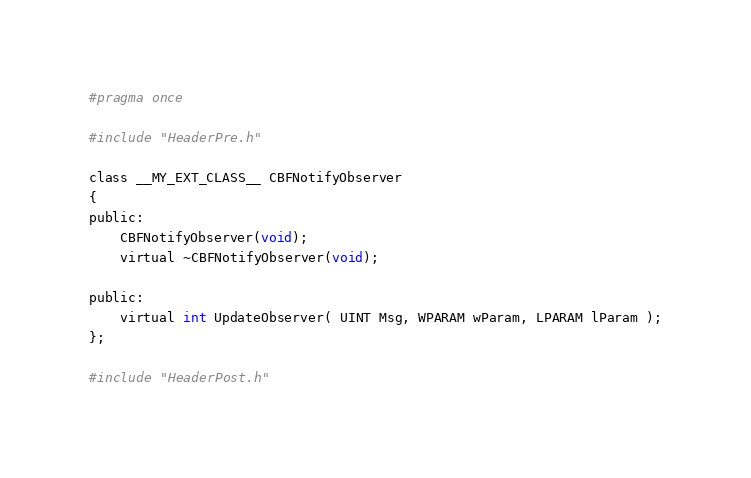Convert code to text. <code><loc_0><loc_0><loc_500><loc_500><_C_>#pragma once

#include "HeaderPre.h"

class __MY_EXT_CLASS__ CBFNotifyObserver
{
public:
	CBFNotifyObserver(void);
	virtual ~CBFNotifyObserver(void);

public:
	virtual int UpdateObserver( UINT Msg, WPARAM wParam, LPARAM lParam );
};

#include "HeaderPost.h"</code> 